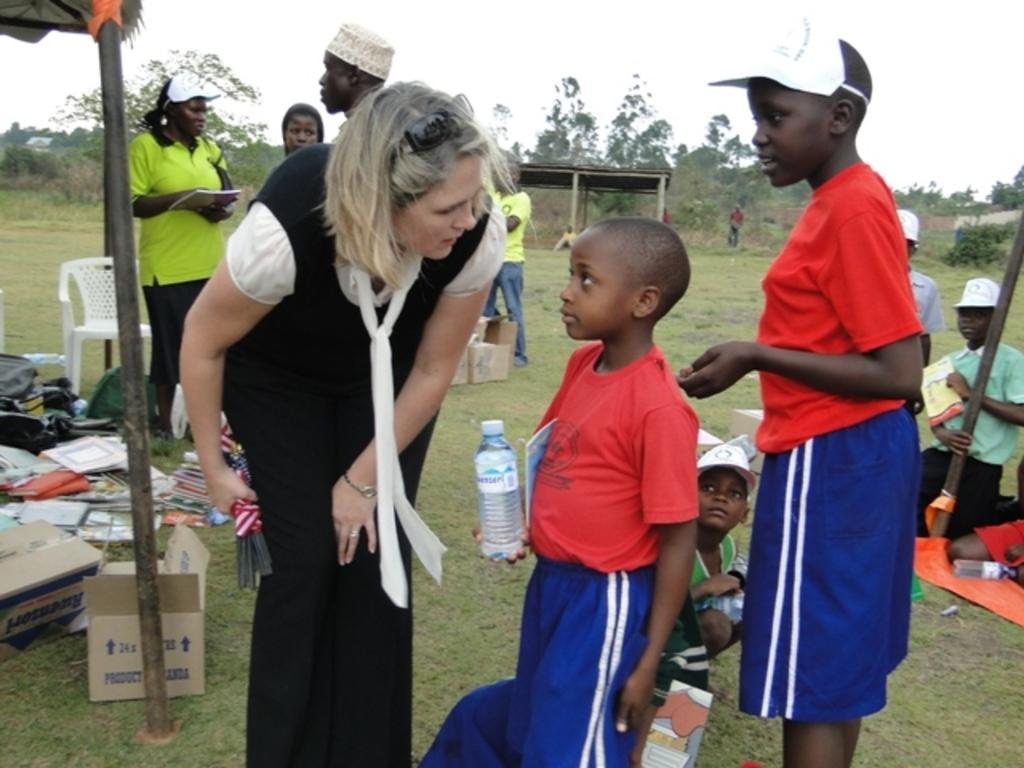In one or two sentences, can you explain what this image depicts? In this image I can see group of people. There are cardboard boxes, poles, water bottles, pillars, books and trees. Also there is grass, shed, a chair and in the background there is sky. 